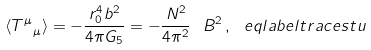<formula> <loc_0><loc_0><loc_500><loc_500>\langle T ^ { \mu } _ { \ \mu } \rangle = - \frac { r _ { 0 } ^ { 4 } b ^ { 2 } } { 4 \pi G _ { 5 } } = - \frac { N ^ { 2 } } { 4 \pi ^ { 2 } } \ B ^ { 2 } \, , \ e q l a b e l { t r a c e s t u }</formula> 